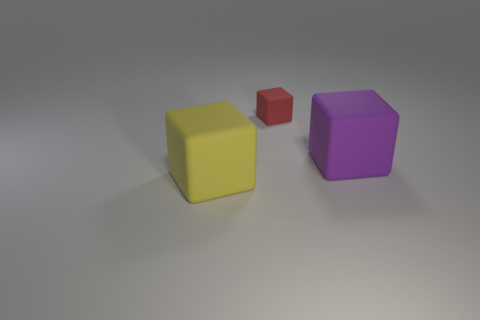What material is the yellow cube that is the same size as the purple rubber block?
Provide a succinct answer. Rubber. Are there any red blocks on the right side of the red matte thing?
Provide a succinct answer. No. Are there an equal number of purple rubber objects that are left of the tiny red matte object and blue matte things?
Give a very brief answer. Yes. There is another matte thing that is the same size as the purple object; what shape is it?
Offer a very short reply. Cube. What is the material of the purple object?
Give a very brief answer. Rubber. What is the color of the rubber thing that is both to the right of the large yellow object and in front of the tiny red thing?
Provide a short and direct response. Purple. Are there an equal number of rubber blocks that are behind the purple rubber block and large yellow objects behind the red matte block?
Give a very brief answer. No. The tiny thing that is made of the same material as the large yellow object is what color?
Give a very brief answer. Red. Is the color of the small matte object the same as the large cube that is left of the purple rubber thing?
Make the answer very short. No. Is there a small red cube on the left side of the tiny rubber object right of the large thing to the left of the large purple block?
Offer a terse response. No. 